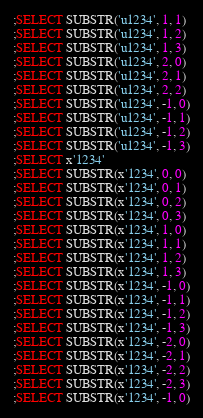<code> <loc_0><loc_0><loc_500><loc_500><_SQL_>;SELECT SUBSTR('u1234', 1, 1)
;SELECT SUBSTR('u1234', 1, 2)
;SELECT SUBSTR('u1234', 1, 3)
;SELECT SUBSTR('u1234', 2, 0)
;SELECT SUBSTR('u1234', 2, 1)
;SELECT SUBSTR('u1234', 2, 2)
;SELECT SUBSTR('u1234', -1, 0)
;SELECT SUBSTR('u1234', -1, 1)
;SELECT SUBSTR('u1234', -1, 2)
;SELECT SUBSTR('u1234', -1, 3)
;SELECT x'1234'
;SELECT SUBSTR(x'1234', 0, 0)
;SELECT SUBSTR(x'1234', 0, 1)
;SELECT SUBSTR(x'1234', 0, 2)
;SELECT SUBSTR(x'1234', 0, 3)
;SELECT SUBSTR(x'1234', 1, 0)
;SELECT SUBSTR(x'1234', 1, 1)
;SELECT SUBSTR(x'1234', 1, 2)
;SELECT SUBSTR(x'1234', 1, 3)
;SELECT SUBSTR(x'1234', -1, 0)
;SELECT SUBSTR(x'1234', -1, 1)
;SELECT SUBSTR(x'1234', -1, 2)
;SELECT SUBSTR(x'1234', -1, 3)
;SELECT SUBSTR(x'1234', -2, 0)
;SELECT SUBSTR(x'1234', -2, 1)
;SELECT SUBSTR(x'1234', -2, 2)
;SELECT SUBSTR(x'1234', -2, 3)
;SELECT SUBSTR(x'1234', -1, 0)</code> 